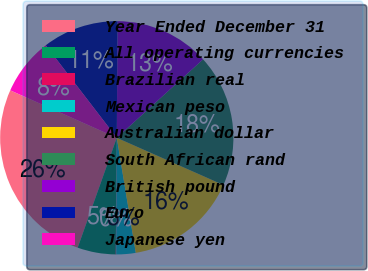<chart> <loc_0><loc_0><loc_500><loc_500><pie_chart><fcel>Year Ended December 31<fcel>All operating currencies<fcel>Brazilian real<fcel>Mexican peso<fcel>Australian dollar<fcel>South African rand<fcel>British pound<fcel>Euro<fcel>Japanese yen<nl><fcel>26.23%<fcel>5.3%<fcel>0.07%<fcel>2.68%<fcel>15.76%<fcel>18.38%<fcel>13.15%<fcel>10.53%<fcel>7.91%<nl></chart> 